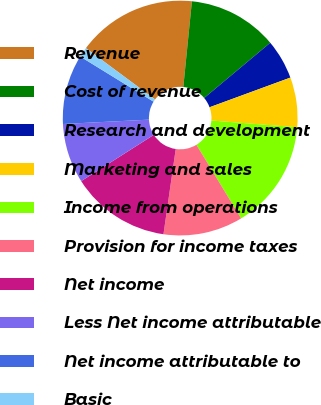Convert chart to OTSL. <chart><loc_0><loc_0><loc_500><loc_500><pie_chart><fcel>Revenue<fcel>Cost of revenue<fcel>Research and development<fcel>Marketing and sales<fcel>Income from operations<fcel>Provision for income taxes<fcel>Net income<fcel>Less Net income attributable<fcel>Net income attributable to<fcel>Basic<nl><fcel>16.44%<fcel>12.33%<fcel>5.48%<fcel>6.85%<fcel>15.07%<fcel>10.96%<fcel>13.7%<fcel>8.22%<fcel>9.59%<fcel>1.37%<nl></chart> 